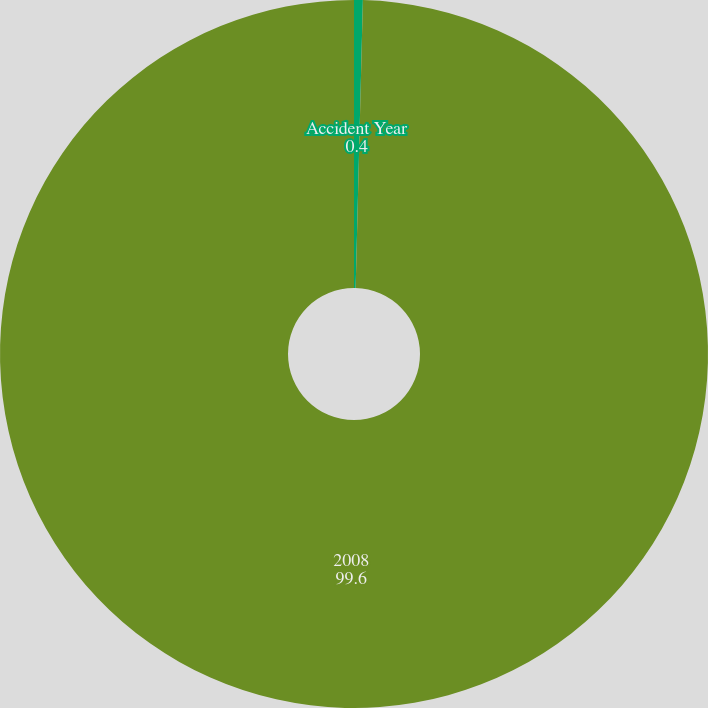<chart> <loc_0><loc_0><loc_500><loc_500><pie_chart><fcel>Accident Year<fcel>2008<nl><fcel>0.4%<fcel>99.6%<nl></chart> 